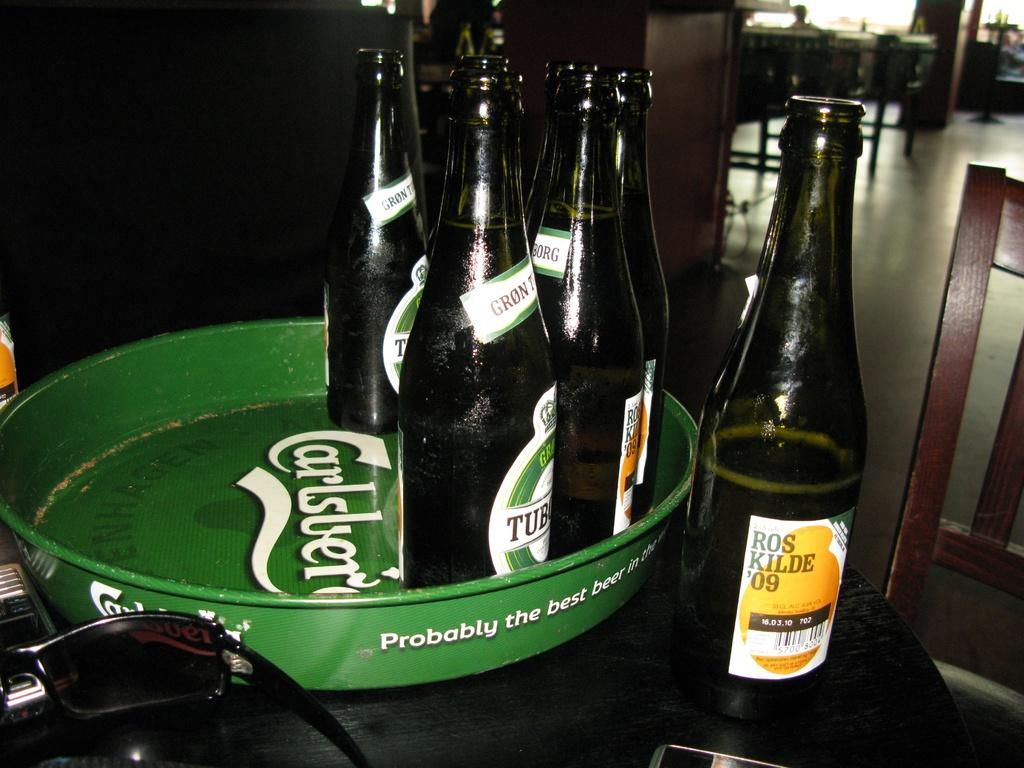<image>
Present a compact description of the photo's key features. A bottle of Ros Kilde 09 next to a tray with bottles on it 